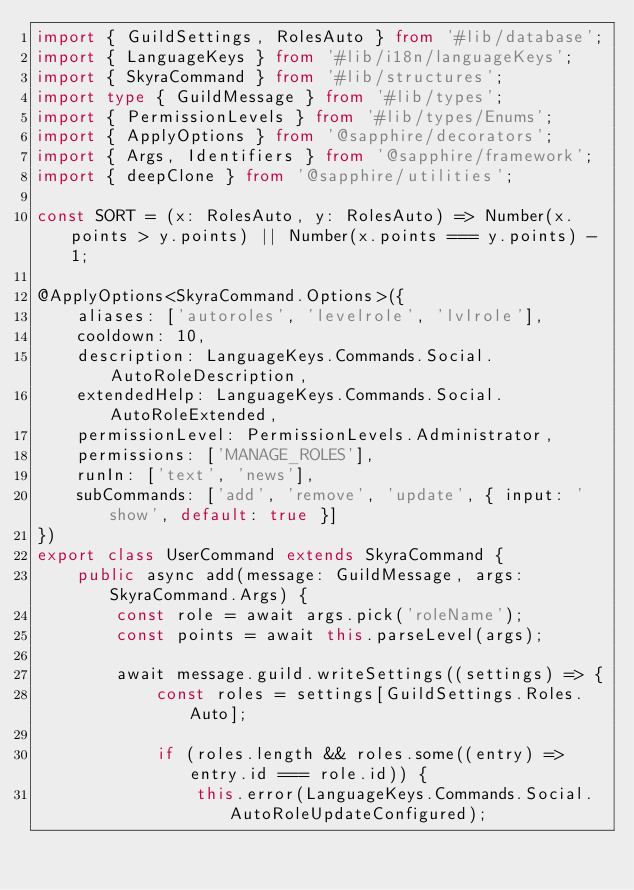Convert code to text. <code><loc_0><loc_0><loc_500><loc_500><_TypeScript_>import { GuildSettings, RolesAuto } from '#lib/database';
import { LanguageKeys } from '#lib/i18n/languageKeys';
import { SkyraCommand } from '#lib/structures';
import type { GuildMessage } from '#lib/types';
import { PermissionLevels } from '#lib/types/Enums';
import { ApplyOptions } from '@sapphire/decorators';
import { Args, Identifiers } from '@sapphire/framework';
import { deepClone } from '@sapphire/utilities';

const SORT = (x: RolesAuto, y: RolesAuto) => Number(x.points > y.points) || Number(x.points === y.points) - 1;

@ApplyOptions<SkyraCommand.Options>({
	aliases: ['autoroles', 'levelrole', 'lvlrole'],
	cooldown: 10,
	description: LanguageKeys.Commands.Social.AutoRoleDescription,
	extendedHelp: LanguageKeys.Commands.Social.AutoRoleExtended,
	permissionLevel: PermissionLevels.Administrator,
	permissions: ['MANAGE_ROLES'],
	runIn: ['text', 'news'],
	subCommands: ['add', 'remove', 'update', { input: 'show', default: true }]
})
export class UserCommand extends SkyraCommand {
	public async add(message: GuildMessage, args: SkyraCommand.Args) {
		const role = await args.pick('roleName');
		const points = await this.parseLevel(args);

		await message.guild.writeSettings((settings) => {
			const roles = settings[GuildSettings.Roles.Auto];

			if (roles.length && roles.some((entry) => entry.id === role.id)) {
				this.error(LanguageKeys.Commands.Social.AutoRoleUpdateConfigured);</code> 